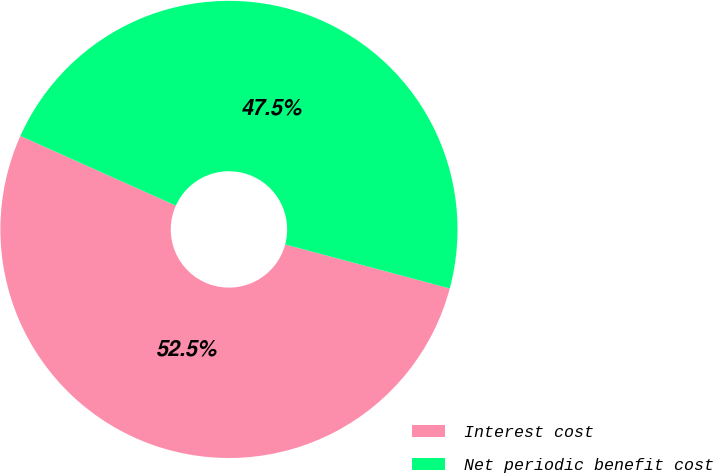Convert chart to OTSL. <chart><loc_0><loc_0><loc_500><loc_500><pie_chart><fcel>Interest cost<fcel>Net periodic benefit cost<nl><fcel>52.55%<fcel>47.45%<nl></chart> 